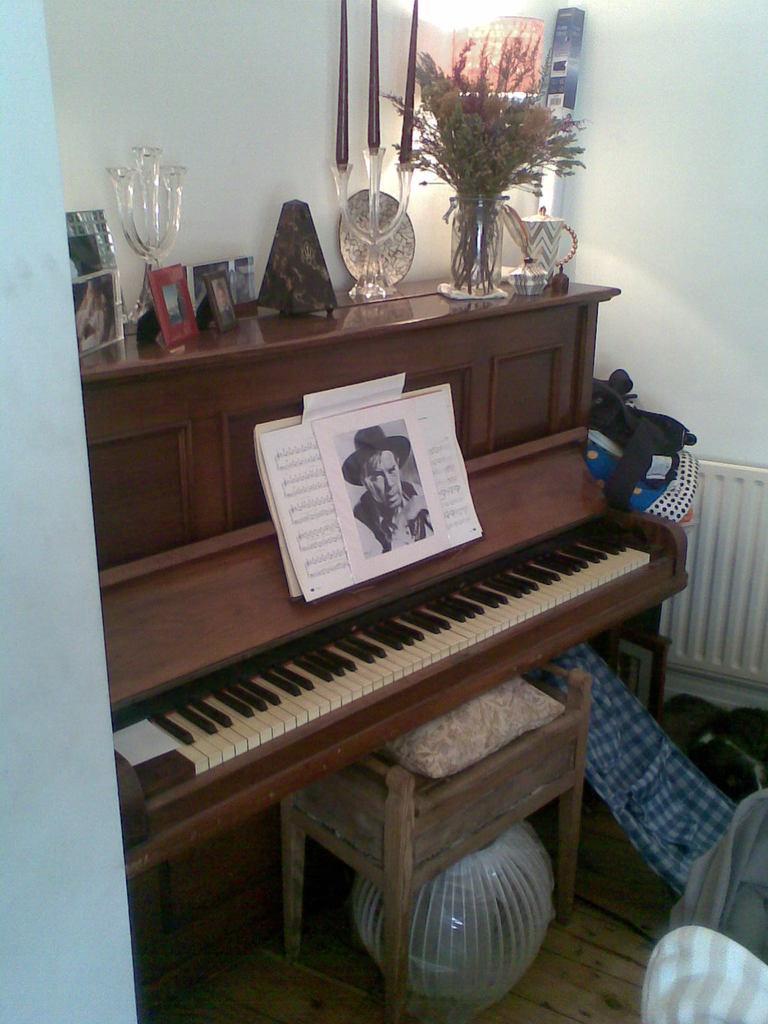Describe this image in one or two sentences. In this image I can see a table on which photo frame, flower vase and decorative items are kept. In front of that a keyboard is there on which poster is kept. The background walls are sky blue in color. In the middle bottom a table is there on which cushion is kept and clothes are visible. This image is taken inside a room. 